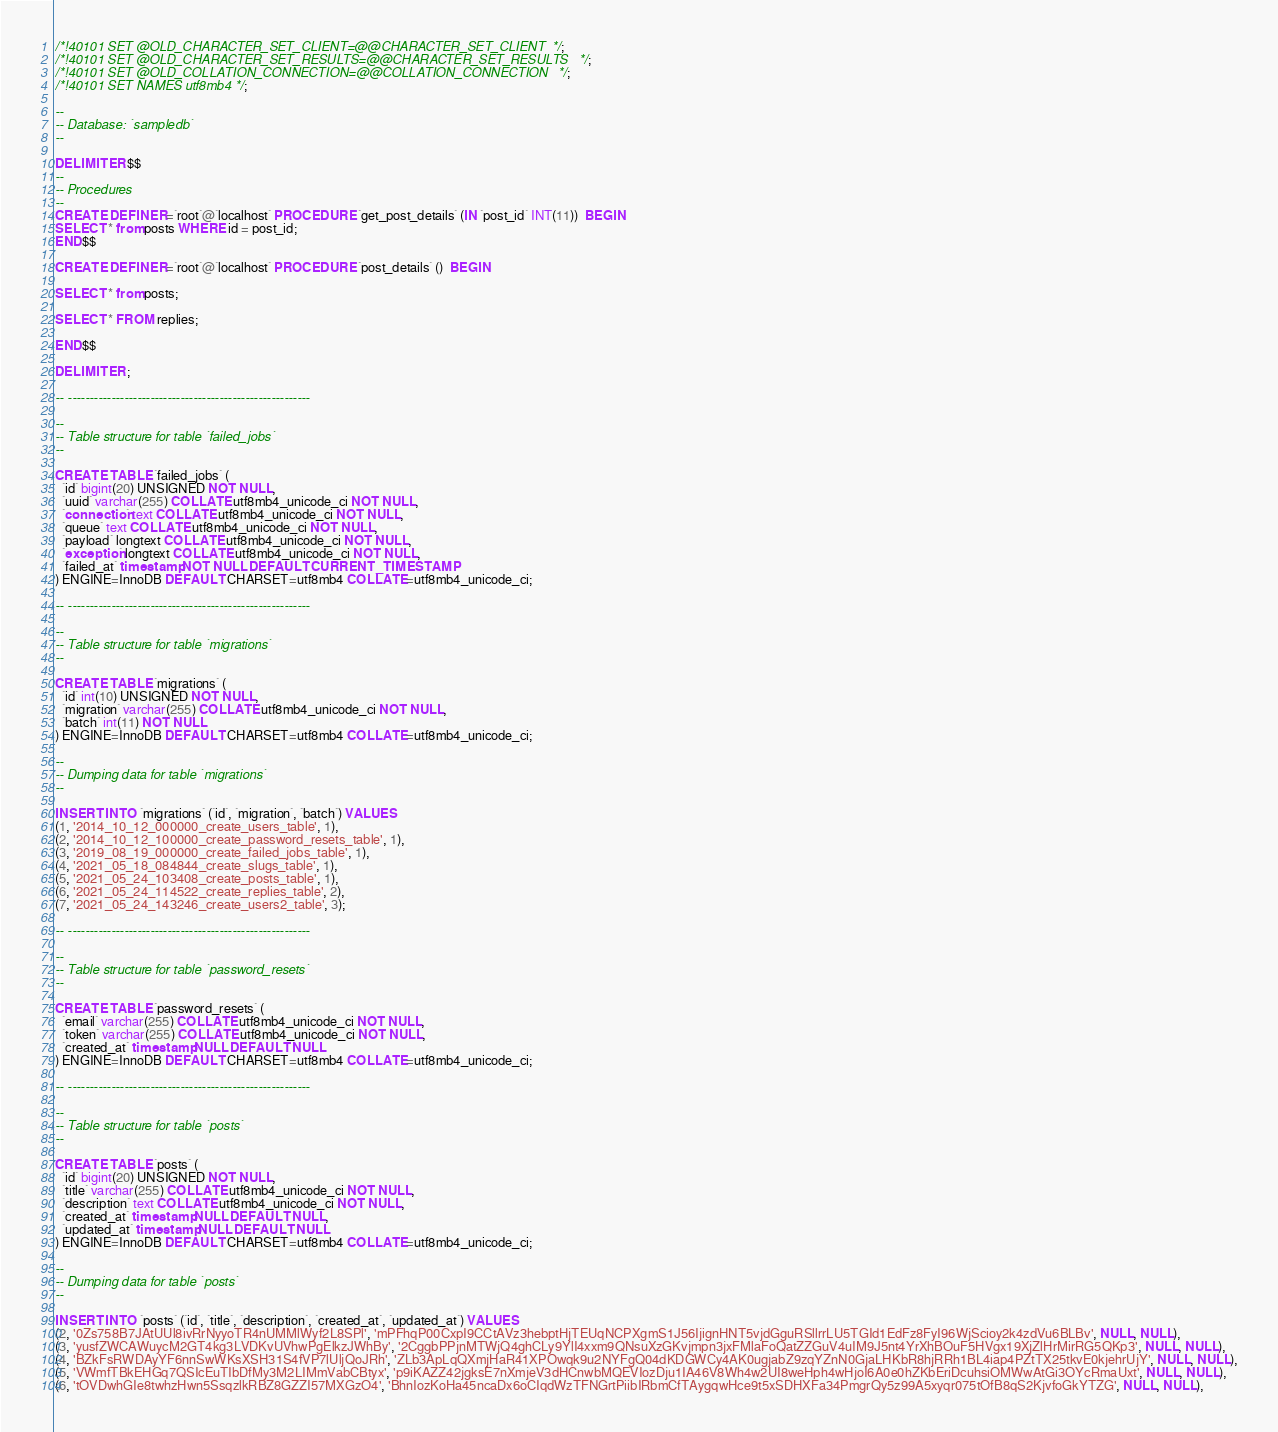Convert code to text. <code><loc_0><loc_0><loc_500><loc_500><_SQL_>

/*!40101 SET @OLD_CHARACTER_SET_CLIENT=@@CHARACTER_SET_CLIENT */;
/*!40101 SET @OLD_CHARACTER_SET_RESULTS=@@CHARACTER_SET_RESULTS */;
/*!40101 SET @OLD_COLLATION_CONNECTION=@@COLLATION_CONNECTION */;
/*!40101 SET NAMES utf8mb4 */;

--
-- Database: `sampledb`
--

DELIMITER $$
--
-- Procedures
--
CREATE DEFINER=`root`@`localhost` PROCEDURE `get_post_details` (IN `post_id` INT(11))  BEGIN
SELECT * from posts WHERE id = post_id;
END$$

CREATE DEFINER=`root`@`localhost` PROCEDURE `post_details` ()  BEGIN

SELECT * from posts;

SELECT * FROM replies;

END$$

DELIMITER ;

-- --------------------------------------------------------

--
-- Table structure for table `failed_jobs`
--

CREATE TABLE `failed_jobs` (
  `id` bigint(20) UNSIGNED NOT NULL,
  `uuid` varchar(255) COLLATE utf8mb4_unicode_ci NOT NULL,
  `connection` text COLLATE utf8mb4_unicode_ci NOT NULL,
  `queue` text COLLATE utf8mb4_unicode_ci NOT NULL,
  `payload` longtext COLLATE utf8mb4_unicode_ci NOT NULL,
  `exception` longtext COLLATE utf8mb4_unicode_ci NOT NULL,
  `failed_at` timestamp NOT NULL DEFAULT CURRENT_TIMESTAMP
) ENGINE=InnoDB DEFAULT CHARSET=utf8mb4 COLLATE=utf8mb4_unicode_ci;

-- --------------------------------------------------------

--
-- Table structure for table `migrations`
--

CREATE TABLE `migrations` (
  `id` int(10) UNSIGNED NOT NULL,
  `migration` varchar(255) COLLATE utf8mb4_unicode_ci NOT NULL,
  `batch` int(11) NOT NULL
) ENGINE=InnoDB DEFAULT CHARSET=utf8mb4 COLLATE=utf8mb4_unicode_ci;

--
-- Dumping data for table `migrations`
--

INSERT INTO `migrations` (`id`, `migration`, `batch`) VALUES
(1, '2014_10_12_000000_create_users_table', 1),
(2, '2014_10_12_100000_create_password_resets_table', 1),
(3, '2019_08_19_000000_create_failed_jobs_table', 1),
(4, '2021_05_18_084844_create_slugs_table', 1),
(5, '2021_05_24_103408_create_posts_table', 1),
(6, '2021_05_24_114522_create_replies_table', 2),
(7, '2021_05_24_143246_create_users2_table', 3);

-- --------------------------------------------------------

--
-- Table structure for table `password_resets`
--

CREATE TABLE `password_resets` (
  `email` varchar(255) COLLATE utf8mb4_unicode_ci NOT NULL,
  `token` varchar(255) COLLATE utf8mb4_unicode_ci NOT NULL,
  `created_at` timestamp NULL DEFAULT NULL
) ENGINE=InnoDB DEFAULT CHARSET=utf8mb4 COLLATE=utf8mb4_unicode_ci;

-- --------------------------------------------------------

--
-- Table structure for table `posts`
--

CREATE TABLE `posts` (
  `id` bigint(20) UNSIGNED NOT NULL,
  `title` varchar(255) COLLATE utf8mb4_unicode_ci NOT NULL,
  `description` text COLLATE utf8mb4_unicode_ci NOT NULL,
  `created_at` timestamp NULL DEFAULT NULL,
  `updated_at` timestamp NULL DEFAULT NULL
) ENGINE=InnoDB DEFAULT CHARSET=utf8mb4 COLLATE=utf8mb4_unicode_ci;

--
-- Dumping data for table `posts`
--

INSERT INTO `posts` (`id`, `title`, `description`, `created_at`, `updated_at`) VALUES
(2, '0Zs758B7JAtUUl8ivRrNyyoTR4nUMMlWyf2L8SPl', 'mPFhqP00CxpI9CCtAVz3hebptHjTEUqNCPXgmS1J56IjignHNT5vjdGguRSllrrLU5TGId1EdFz8FyI96WjScioy2k4zdVu6BLBv', NULL, NULL),
(3, 'yusfZWCAWuycM2GT4kg3LVDKvUVhwPgElkzJWhBy', '2CggbPPjnMTWjQ4ghCLy9YlI4xxm9QNsuXzGKvjmpn3jxFMlaFoQatZZGuV4uIM9J5nt4YrXhBOuF5HVgx19XjZlHrMirRG5QKp3', NULL, NULL),
(4, 'BZkFsRWDAyYF6nnSwWKsXSH31S4fVP7lUljQoJRh', 'ZLb3ApLqQXmjHaR41XPOwqk9u2NYFgQ04dKDGWCy4AK0ugjabZ9zqYZnN0GjaLHKbR8hjRRh1BL4iap4PZtTX25tkvE0kjehrUjY', NULL, NULL),
(5, 'VWmfTBkEHGq7QSIcEuTIbDfMy3M2LIMmVabCBtyx', 'p9iKAZZ42jgksE7nXmjeV3dHCnwbMQEVIozDju1IA46V8Wh4w2UI8weHph4wHjoI6A0e0hZKbEriDcuhsiOMWwAtGi3OYcRmaUxt', NULL, NULL),
(6, 'tOVDwhGIe8twhzHwn5SsqzlkRBZ8GZZI57MXGzO4', 'BhnIozKoHa45ncaDx6oCIqdWzTFNGrtPiibIRbmCfTAygqwHce9t5xSDHXFa34PmgrQy5z99A5xyqr075tOfB8qS2KjvfoGkYTZG', NULL, NULL),</code> 